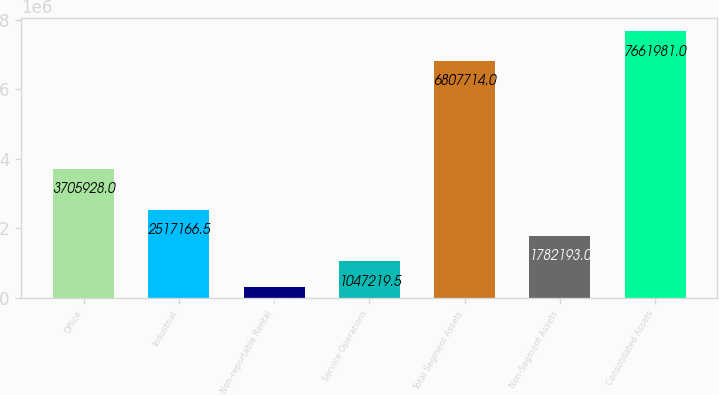Convert chart. <chart><loc_0><loc_0><loc_500><loc_500><bar_chart><fcel>Office<fcel>Industrial<fcel>Non-reportable Rental<fcel>Service Operations<fcel>Total Segment Assets<fcel>Non-Segment Assets<fcel>Consolidated Assets<nl><fcel>3.70593e+06<fcel>2.51717e+06<fcel>312246<fcel>1.04722e+06<fcel>6.80771e+06<fcel>1.78219e+06<fcel>7.66198e+06<nl></chart> 